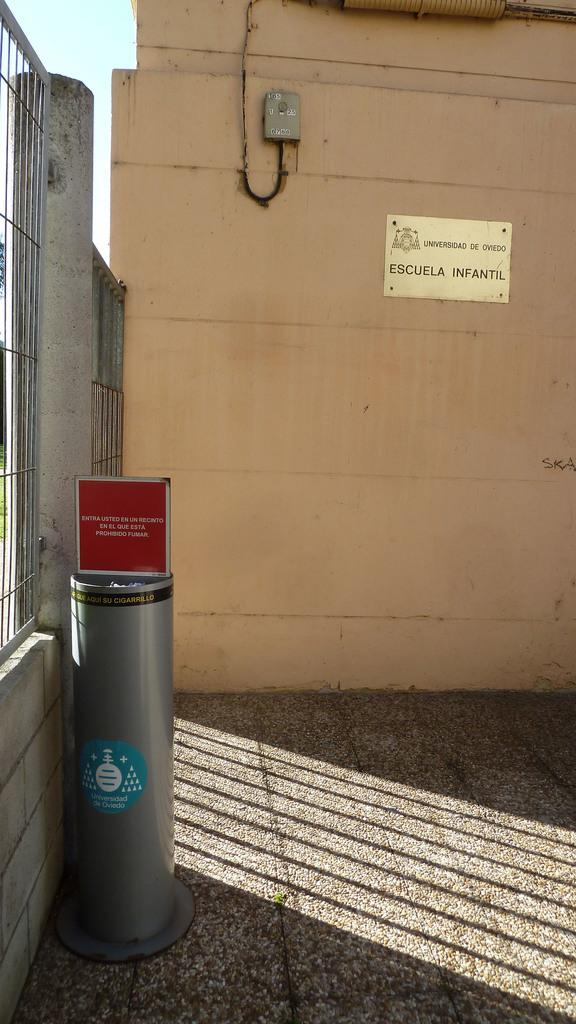Provide a one-sentence caption for the provided image. a sign with the word escuela on it. 